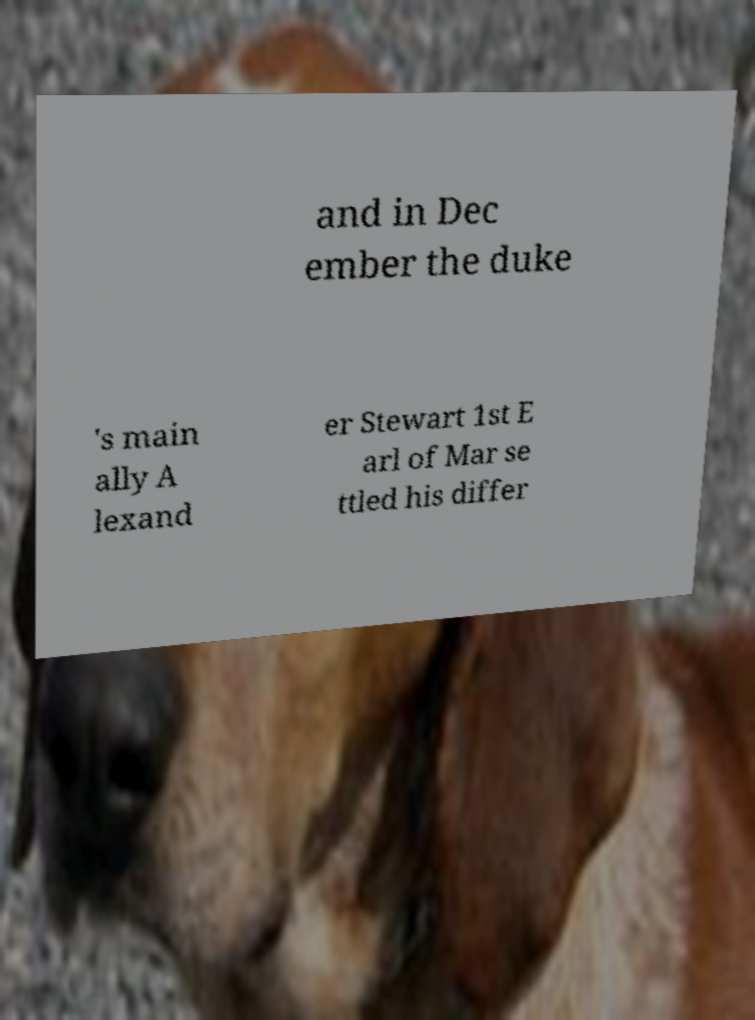Please read and relay the text visible in this image. What does it say? and in Dec ember the duke 's main ally A lexand er Stewart 1st E arl of Mar se ttled his differ 